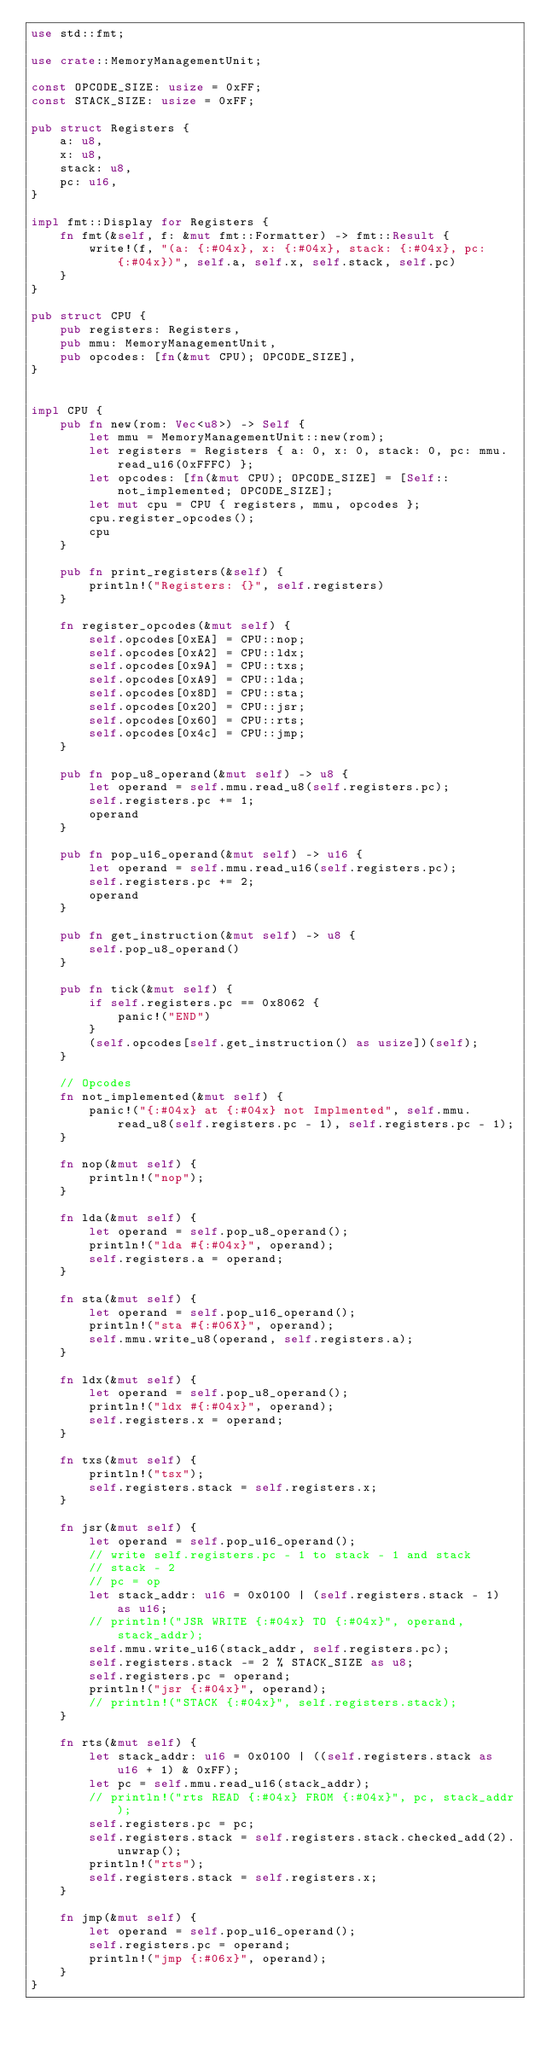<code> <loc_0><loc_0><loc_500><loc_500><_Rust_>use std::fmt;

use crate::MemoryManagementUnit;

const OPCODE_SIZE: usize = 0xFF;
const STACK_SIZE: usize = 0xFF;

pub struct Registers {
    a: u8,
    x: u8,
    stack: u8,
    pc: u16,
}

impl fmt::Display for Registers {
    fn fmt(&self, f: &mut fmt::Formatter) -> fmt::Result {
        write!(f, "(a: {:#04x}, x: {:#04x}, stack: {:#04x}, pc: {:#04x})", self.a, self.x, self.stack, self.pc)
    }
}

pub struct CPU {
    pub registers: Registers,
    pub mmu: MemoryManagementUnit,
    pub opcodes: [fn(&mut CPU); OPCODE_SIZE],
}


impl CPU {
    pub fn new(rom: Vec<u8>) -> Self {
        let mmu = MemoryManagementUnit::new(rom);
        let registers = Registers { a: 0, x: 0, stack: 0, pc: mmu.read_u16(0xFFFC) };
        let opcodes: [fn(&mut CPU); OPCODE_SIZE] = [Self::not_implemented; OPCODE_SIZE];
        let mut cpu = CPU { registers, mmu, opcodes };
        cpu.register_opcodes();
        cpu
    }

    pub fn print_registers(&self) {
        println!("Registers: {}", self.registers)
    }

    fn register_opcodes(&mut self) {
        self.opcodes[0xEA] = CPU::nop;
        self.opcodes[0xA2] = CPU::ldx;
        self.opcodes[0x9A] = CPU::txs;
        self.opcodes[0xA9] = CPU::lda;
        self.opcodes[0x8D] = CPU::sta;
        self.opcodes[0x20] = CPU::jsr;
        self.opcodes[0x60] = CPU::rts;
        self.opcodes[0x4c] = CPU::jmp;
    }

    pub fn pop_u8_operand(&mut self) -> u8 {
        let operand = self.mmu.read_u8(self.registers.pc);
        self.registers.pc += 1;
        operand
    }

    pub fn pop_u16_operand(&mut self) -> u16 {
        let operand = self.mmu.read_u16(self.registers.pc);
        self.registers.pc += 2;
        operand
    }

    pub fn get_instruction(&mut self) -> u8 {
        self.pop_u8_operand()
    }

    pub fn tick(&mut self) {
        if self.registers.pc == 0x8062 {
            panic!("END")
        }
        (self.opcodes[self.get_instruction() as usize])(self);
    }

    // Opcodes
    fn not_implemented(&mut self) {
        panic!("{:#04x} at {:#04x} not Implmented", self.mmu.read_u8(self.registers.pc - 1), self.registers.pc - 1);
    }

    fn nop(&mut self) {
        println!("nop");
    }

    fn lda(&mut self) {
        let operand = self.pop_u8_operand();
        println!("lda #{:#04x}", operand);
        self.registers.a = operand;
    }

    fn sta(&mut self) {
        let operand = self.pop_u16_operand();
        println!("sta #{:#06X}", operand);
        self.mmu.write_u8(operand, self.registers.a);
    }

    fn ldx(&mut self) {
        let operand = self.pop_u8_operand();
        println!("ldx #{:#04x}", operand);
        self.registers.x = operand;
    }

    fn txs(&mut self) {
        println!("tsx");
        self.registers.stack = self.registers.x;
    }

    fn jsr(&mut self) {
        let operand = self.pop_u16_operand();
        // write self.registers.pc - 1 to stack - 1 and stack
        // stack - 2
        // pc = op
        let stack_addr: u16 = 0x0100 | (self.registers.stack - 1) as u16;
        // println!("JSR WRITE {:#04x} TO {:#04x}", operand, stack_addr);
        self.mmu.write_u16(stack_addr, self.registers.pc);
        self.registers.stack -= 2 % STACK_SIZE as u8;
        self.registers.pc = operand;
        println!("jsr {:#04x}", operand);
        // println!("STACK {:#04x}", self.registers.stack);
    }

    fn rts(&mut self) {
        let stack_addr: u16 = 0x0100 | ((self.registers.stack as u16 + 1) & 0xFF);
        let pc = self.mmu.read_u16(stack_addr);
        // println!("rts READ {:#04x} FROM {:#04x}", pc, stack_addr);
        self.registers.pc = pc;
        self.registers.stack = self.registers.stack.checked_add(2).unwrap();
        println!("rts");
        self.registers.stack = self.registers.x;
    }

    fn jmp(&mut self) {
        let operand = self.pop_u16_operand();
        self.registers.pc = operand;
        println!("jmp {:#06x}", operand);
    }
}
</code> 